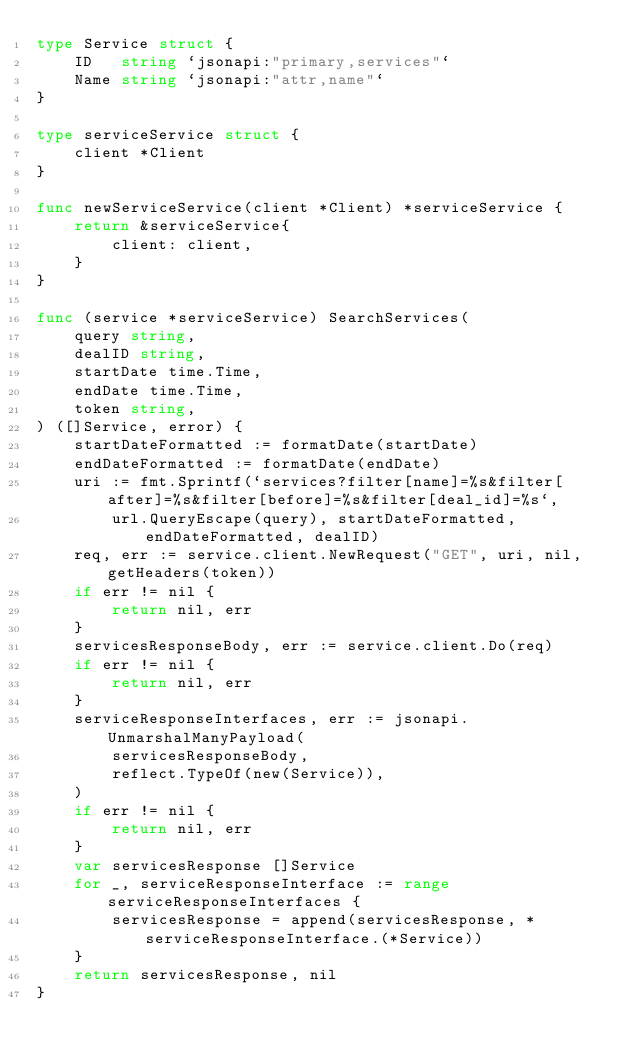Convert code to text. <code><loc_0><loc_0><loc_500><loc_500><_Go_>type Service struct {
	ID   string `jsonapi:"primary,services"`
	Name string `jsonapi:"attr,name"`
}

type serviceService struct {
	client *Client
}

func newServiceService(client *Client) *serviceService {
	return &serviceService{
		client: client,
	}
}

func (service *serviceService) SearchServices(
	query string,
	dealID string,
	startDate time.Time,
	endDate time.Time,
	token string,
) ([]Service, error) {
	startDateFormatted := formatDate(startDate)
	endDateFormatted := formatDate(endDate)
	uri := fmt.Sprintf(`services?filter[name]=%s&filter[after]=%s&filter[before]=%s&filter[deal_id]=%s`,
		url.QueryEscape(query), startDateFormatted, endDateFormatted, dealID)
	req, err := service.client.NewRequest("GET", uri, nil, getHeaders(token))
	if err != nil {
		return nil, err
	}
	servicesResponseBody, err := service.client.Do(req)
	if err != nil {
		return nil, err
	}
	serviceResponseInterfaces, err := jsonapi.UnmarshalManyPayload(
		servicesResponseBody,
		reflect.TypeOf(new(Service)),
	)
	if err != nil {
		return nil, err
	}
	var servicesResponse []Service
	for _, serviceResponseInterface := range serviceResponseInterfaces {
		servicesResponse = append(servicesResponse, *serviceResponseInterface.(*Service))
	}
	return servicesResponse, nil
}
</code> 